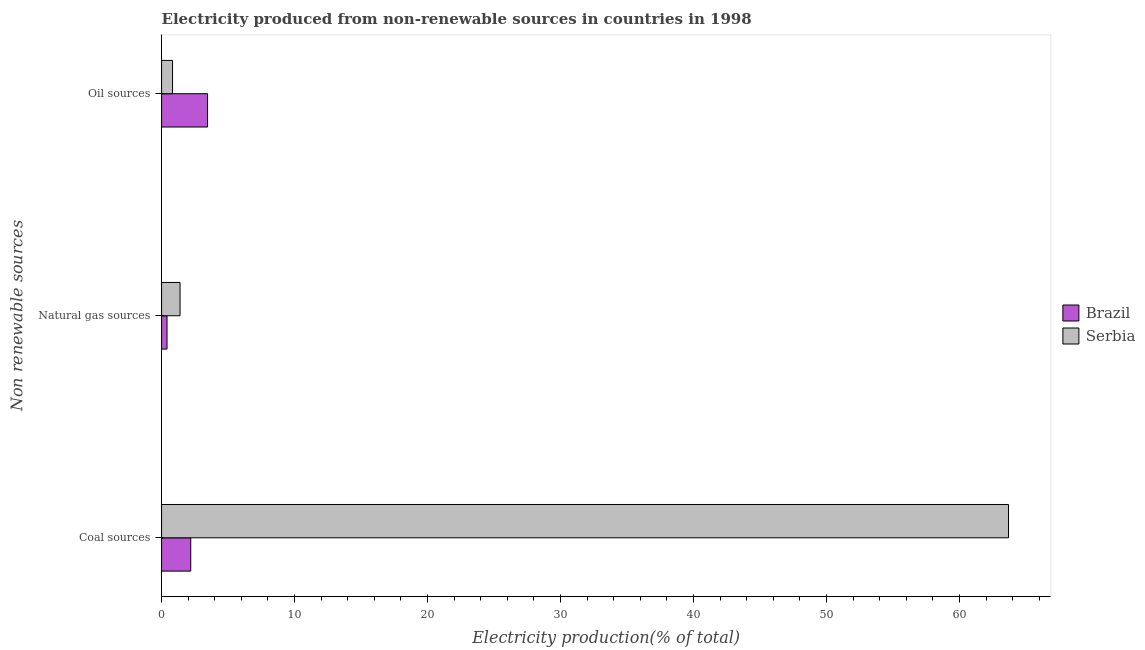How many different coloured bars are there?
Your answer should be compact. 2. Are the number of bars on each tick of the Y-axis equal?
Your response must be concise. Yes. How many bars are there on the 1st tick from the top?
Offer a very short reply. 2. How many bars are there on the 3rd tick from the bottom?
Make the answer very short. 2. What is the label of the 3rd group of bars from the top?
Your answer should be very brief. Coal sources. What is the percentage of electricity produced by natural gas in Serbia?
Give a very brief answer. 1.39. Across all countries, what is the maximum percentage of electricity produced by coal?
Offer a very short reply. 63.69. Across all countries, what is the minimum percentage of electricity produced by coal?
Ensure brevity in your answer.  2.19. In which country was the percentage of electricity produced by coal maximum?
Offer a very short reply. Serbia. In which country was the percentage of electricity produced by natural gas minimum?
Make the answer very short. Brazil. What is the total percentage of electricity produced by oil sources in the graph?
Make the answer very short. 4.28. What is the difference between the percentage of electricity produced by oil sources in Serbia and that in Brazil?
Ensure brevity in your answer.  -2.63. What is the difference between the percentage of electricity produced by coal in Serbia and the percentage of electricity produced by oil sources in Brazil?
Offer a terse response. 60.23. What is the average percentage of electricity produced by coal per country?
Keep it short and to the point. 32.94. What is the difference between the percentage of electricity produced by coal and percentage of electricity produced by natural gas in Brazil?
Make the answer very short. 1.78. In how many countries, is the percentage of electricity produced by oil sources greater than 26 %?
Provide a succinct answer. 0. What is the ratio of the percentage of electricity produced by coal in Serbia to that in Brazil?
Provide a succinct answer. 29.04. What is the difference between the highest and the second highest percentage of electricity produced by coal?
Your answer should be very brief. 61.49. What is the difference between the highest and the lowest percentage of electricity produced by natural gas?
Provide a succinct answer. 0.98. What does the 1st bar from the top in Natural gas sources represents?
Give a very brief answer. Serbia. What does the 1st bar from the bottom in Oil sources represents?
Your answer should be very brief. Brazil. Are all the bars in the graph horizontal?
Offer a terse response. Yes. Are the values on the major ticks of X-axis written in scientific E-notation?
Your answer should be very brief. No. How many legend labels are there?
Keep it short and to the point. 2. How are the legend labels stacked?
Keep it short and to the point. Vertical. What is the title of the graph?
Ensure brevity in your answer.  Electricity produced from non-renewable sources in countries in 1998. Does "Mali" appear as one of the legend labels in the graph?
Your response must be concise. No. What is the label or title of the Y-axis?
Provide a short and direct response. Non renewable sources. What is the Electricity production(% of total) of Brazil in Coal sources?
Provide a succinct answer. 2.19. What is the Electricity production(% of total) in Serbia in Coal sources?
Your response must be concise. 63.69. What is the Electricity production(% of total) in Brazil in Natural gas sources?
Your answer should be compact. 0.41. What is the Electricity production(% of total) in Serbia in Natural gas sources?
Your answer should be very brief. 1.39. What is the Electricity production(% of total) of Brazil in Oil sources?
Your response must be concise. 3.46. What is the Electricity production(% of total) in Serbia in Oil sources?
Provide a short and direct response. 0.83. Across all Non renewable sources, what is the maximum Electricity production(% of total) of Brazil?
Ensure brevity in your answer.  3.46. Across all Non renewable sources, what is the maximum Electricity production(% of total) in Serbia?
Give a very brief answer. 63.69. Across all Non renewable sources, what is the minimum Electricity production(% of total) of Brazil?
Ensure brevity in your answer.  0.41. Across all Non renewable sources, what is the minimum Electricity production(% of total) in Serbia?
Provide a succinct answer. 0.83. What is the total Electricity production(% of total) of Brazil in the graph?
Offer a terse response. 6.06. What is the total Electricity production(% of total) in Serbia in the graph?
Ensure brevity in your answer.  65.9. What is the difference between the Electricity production(% of total) in Brazil in Coal sources and that in Natural gas sources?
Give a very brief answer. 1.78. What is the difference between the Electricity production(% of total) of Serbia in Coal sources and that in Natural gas sources?
Offer a very short reply. 62.3. What is the difference between the Electricity production(% of total) of Brazil in Coal sources and that in Oil sources?
Ensure brevity in your answer.  -1.27. What is the difference between the Electricity production(% of total) in Serbia in Coal sources and that in Oil sources?
Provide a succinct answer. 62.86. What is the difference between the Electricity production(% of total) of Brazil in Natural gas sources and that in Oil sources?
Your response must be concise. -3.05. What is the difference between the Electricity production(% of total) in Serbia in Natural gas sources and that in Oil sources?
Provide a short and direct response. 0.56. What is the difference between the Electricity production(% of total) of Brazil in Coal sources and the Electricity production(% of total) of Serbia in Natural gas sources?
Provide a succinct answer. 0.8. What is the difference between the Electricity production(% of total) in Brazil in Coal sources and the Electricity production(% of total) in Serbia in Oil sources?
Offer a terse response. 1.37. What is the difference between the Electricity production(% of total) of Brazil in Natural gas sources and the Electricity production(% of total) of Serbia in Oil sources?
Give a very brief answer. -0.41. What is the average Electricity production(% of total) of Brazil per Non renewable sources?
Offer a terse response. 2.02. What is the average Electricity production(% of total) in Serbia per Non renewable sources?
Ensure brevity in your answer.  21.97. What is the difference between the Electricity production(% of total) of Brazil and Electricity production(% of total) of Serbia in Coal sources?
Offer a very short reply. -61.49. What is the difference between the Electricity production(% of total) of Brazil and Electricity production(% of total) of Serbia in Natural gas sources?
Provide a short and direct response. -0.98. What is the difference between the Electricity production(% of total) of Brazil and Electricity production(% of total) of Serbia in Oil sources?
Provide a succinct answer. 2.63. What is the ratio of the Electricity production(% of total) of Brazil in Coal sources to that in Natural gas sources?
Provide a succinct answer. 5.34. What is the ratio of the Electricity production(% of total) of Serbia in Coal sources to that in Natural gas sources?
Ensure brevity in your answer.  45.86. What is the ratio of the Electricity production(% of total) of Brazil in Coal sources to that in Oil sources?
Keep it short and to the point. 0.63. What is the ratio of the Electricity production(% of total) in Serbia in Coal sources to that in Oil sources?
Offer a very short reply. 77.18. What is the ratio of the Electricity production(% of total) in Brazil in Natural gas sources to that in Oil sources?
Provide a succinct answer. 0.12. What is the ratio of the Electricity production(% of total) of Serbia in Natural gas sources to that in Oil sources?
Provide a short and direct response. 1.68. What is the difference between the highest and the second highest Electricity production(% of total) of Brazil?
Ensure brevity in your answer.  1.27. What is the difference between the highest and the second highest Electricity production(% of total) of Serbia?
Keep it short and to the point. 62.3. What is the difference between the highest and the lowest Electricity production(% of total) of Brazil?
Your response must be concise. 3.05. What is the difference between the highest and the lowest Electricity production(% of total) in Serbia?
Your answer should be compact. 62.86. 